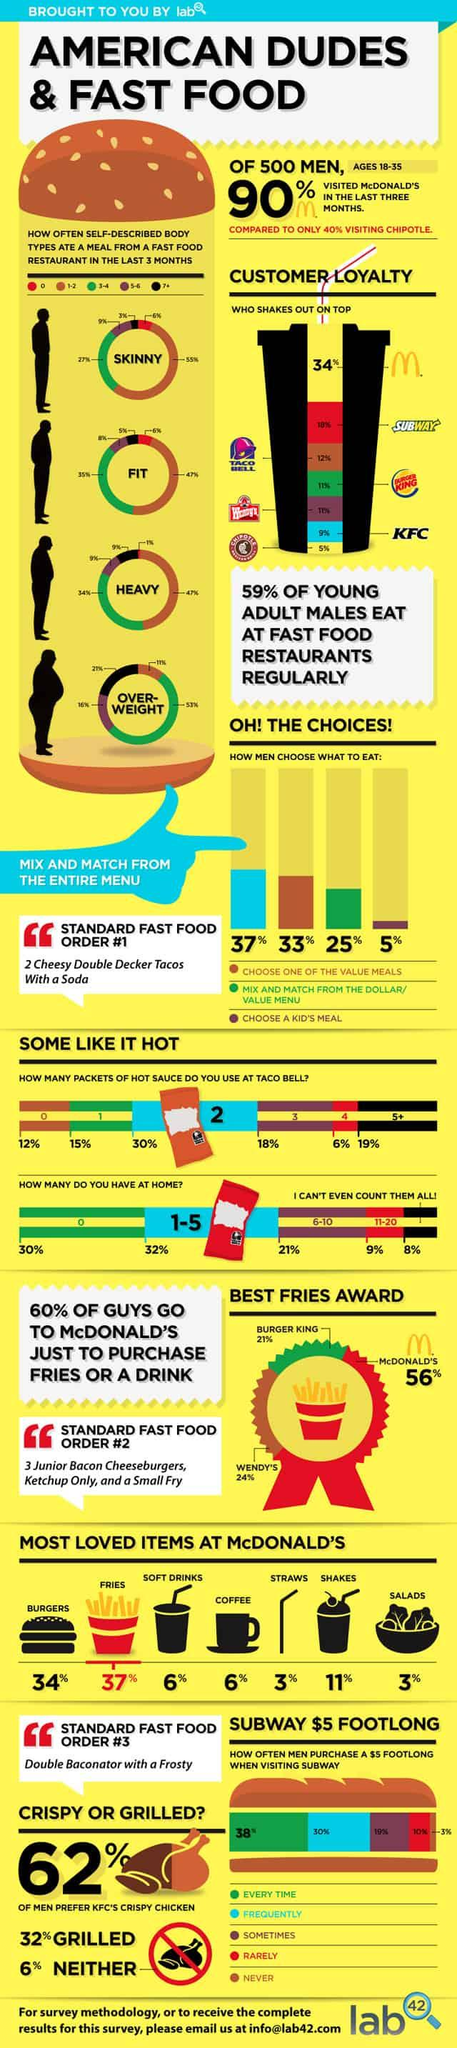List a handful of essential elements in this visual. According to a survey, 19% of people use more than 5 hot sauce packets at Taco Bell. According to the data, only 3% of individuals with a skinny body type consume 7 or more meals from a fast food restaurant in the last three months. According to a recent survey, 37% of men choose to mix and match from the menu when dining out. Approximately 35% of individuals with fit bodies reported eating 3-4 meals in the last 3 months from fast food restaurants. According to a recent survey, 10% of women between the ages of 18 and 35 visited McDonald's in the last three months. 